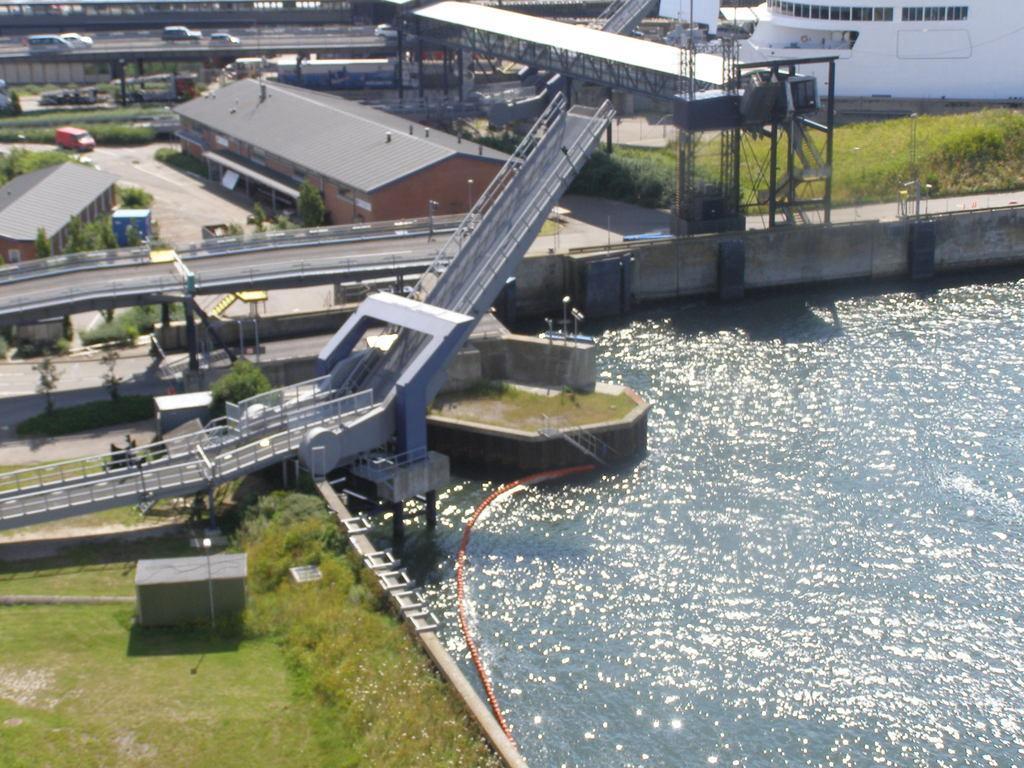Describe this image in one or two sentences. In this image I can see the water, a orange colored pipe, some grass and few plants on the ground, a bridge, few vehicles on the bridge, few buildings and few trees. In the background I can see few bridges and few vehicles on them. 